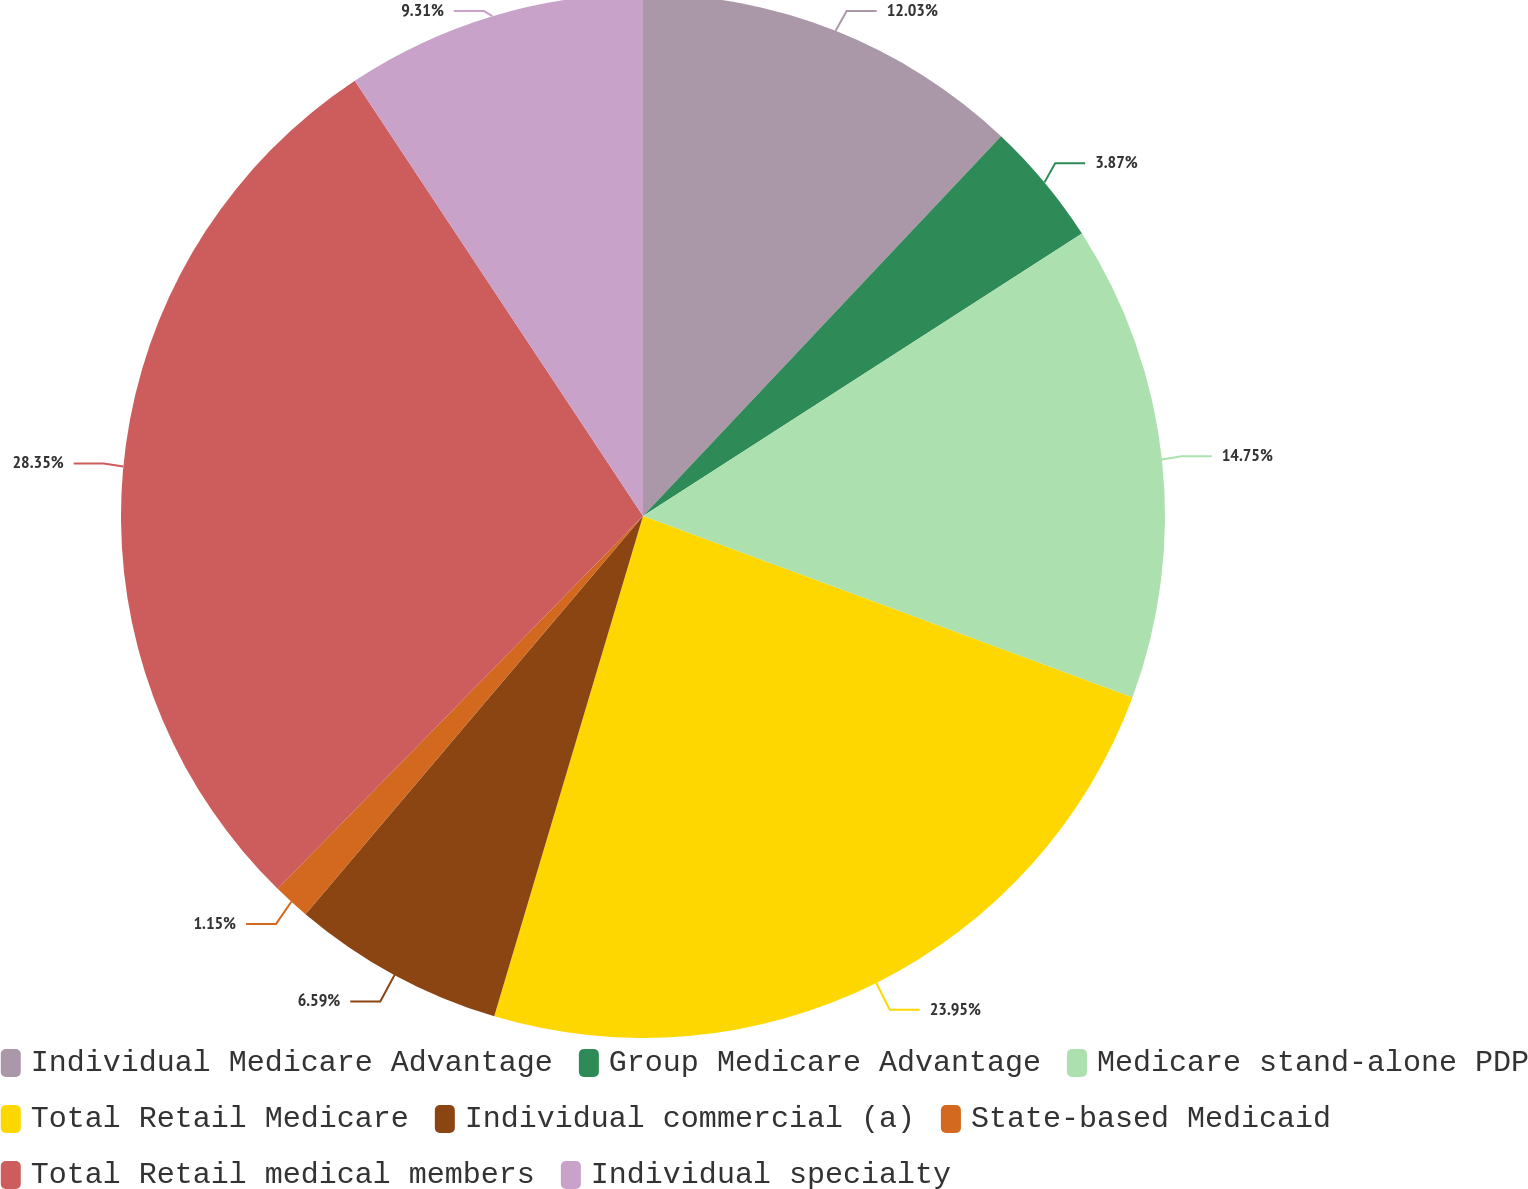Convert chart. <chart><loc_0><loc_0><loc_500><loc_500><pie_chart><fcel>Individual Medicare Advantage<fcel>Group Medicare Advantage<fcel>Medicare stand-alone PDP<fcel>Total Retail Medicare<fcel>Individual commercial (a)<fcel>State-based Medicaid<fcel>Total Retail medical members<fcel>Individual specialty<nl><fcel>12.03%<fcel>3.87%<fcel>14.75%<fcel>23.95%<fcel>6.59%<fcel>1.15%<fcel>28.35%<fcel>9.31%<nl></chart> 